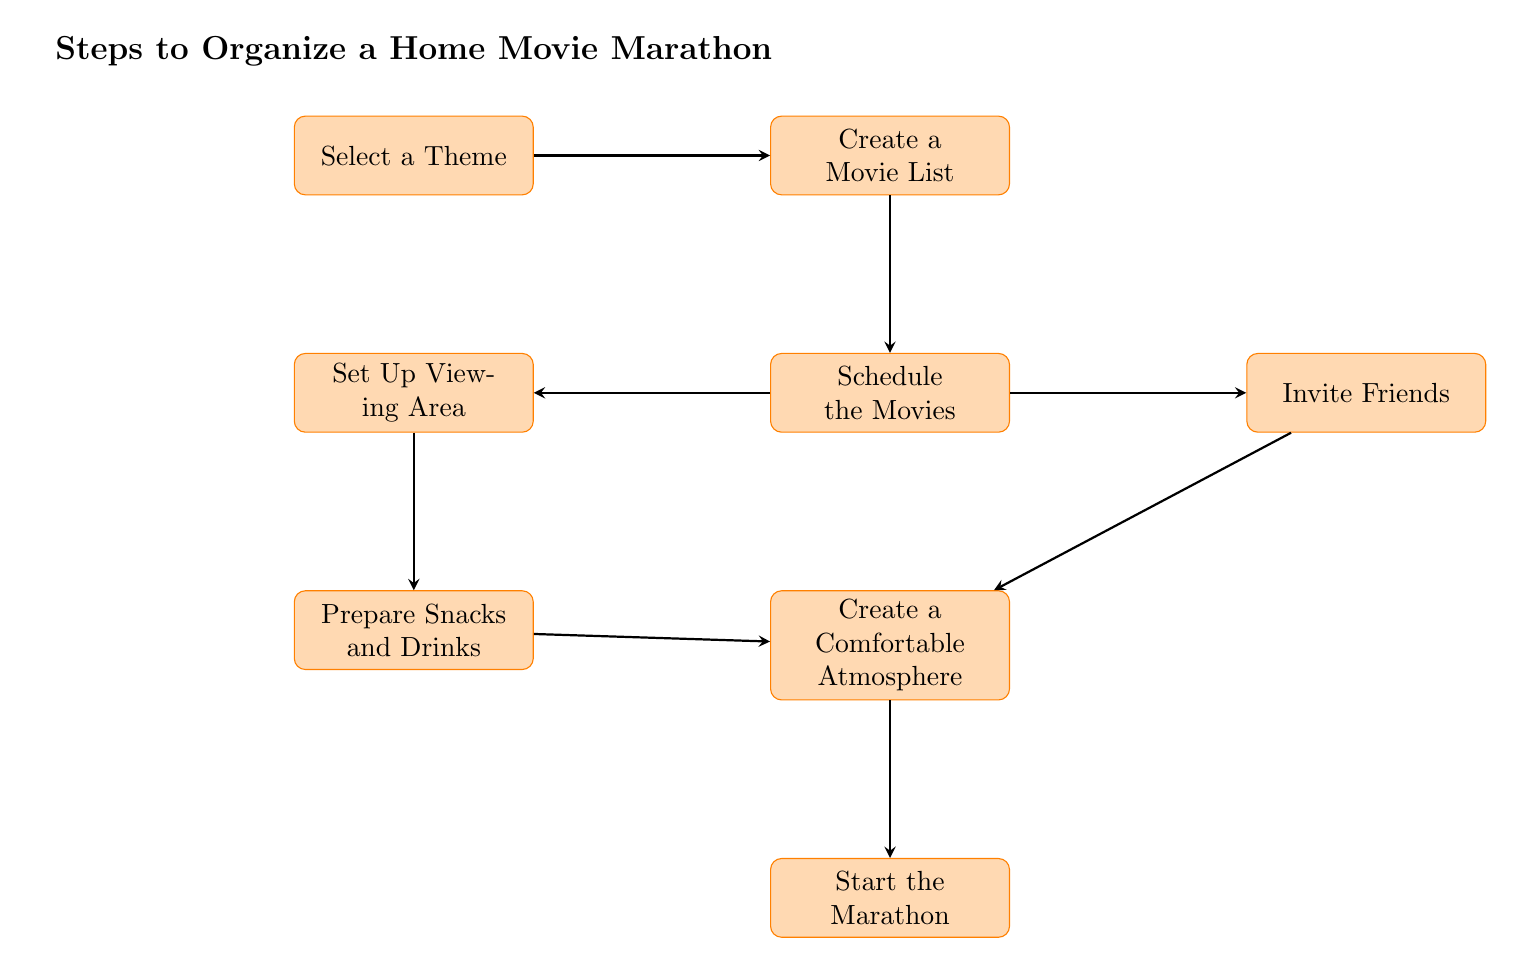What is the first step to organize a home movie marathon? The first node in the flow chart is "Select a Theme," indicating that this is the initial step in the process.
Answer: Select a Theme How many total steps are there in the diagram? By counting each of the nodes listed in the flow chart, there are a total of eight steps.
Answer: Eight Which two nodes are connected to the "Schedule the Movies" node? The "Schedule the Movies" node connects to both "Set Up Viewing Area" and "Invite Friends," as shown by the arrows leading from "Schedule the Movies" to these nodes.
Answer: Set Up Viewing Area and Invite Friends What is the last step in the movie marathon organization? The last node in the flow chart is "Start the Marathon," which is the final step in the process.
Answer: Start the Marathon What should be prepared before creating the movie list? The first action, according to the flow chart, is to select a theme, which must be completed before moving on to creating the movie list.
Answer: Select a Theme Which node follows "Create a Movie List"? The node directly after "Create a Movie List" is "Schedule the Movies," as illustrated by the arrow connecting these two nodes.
Answer: Schedule the Movies How does "Prepare Snacks and Drinks" relate to "Set Up Viewing Area"? "Prepare Snacks and Drinks" follows "Set Up Viewing Area" in the flow chart, indicating that snacks preparation occurs after the viewing area setup is complete.
Answer: It follows it What node is connected to both "Invite Friends" and "Create a Comfortable Atmosphere"? Both arrows point toward "Create a Comfortable Atmosphere," which is the node that directly follows the "Invite Friends" and is also influenced by the "Prepare Snacks and Drinks" node.
Answer: Create a Comfortable Atmosphere 